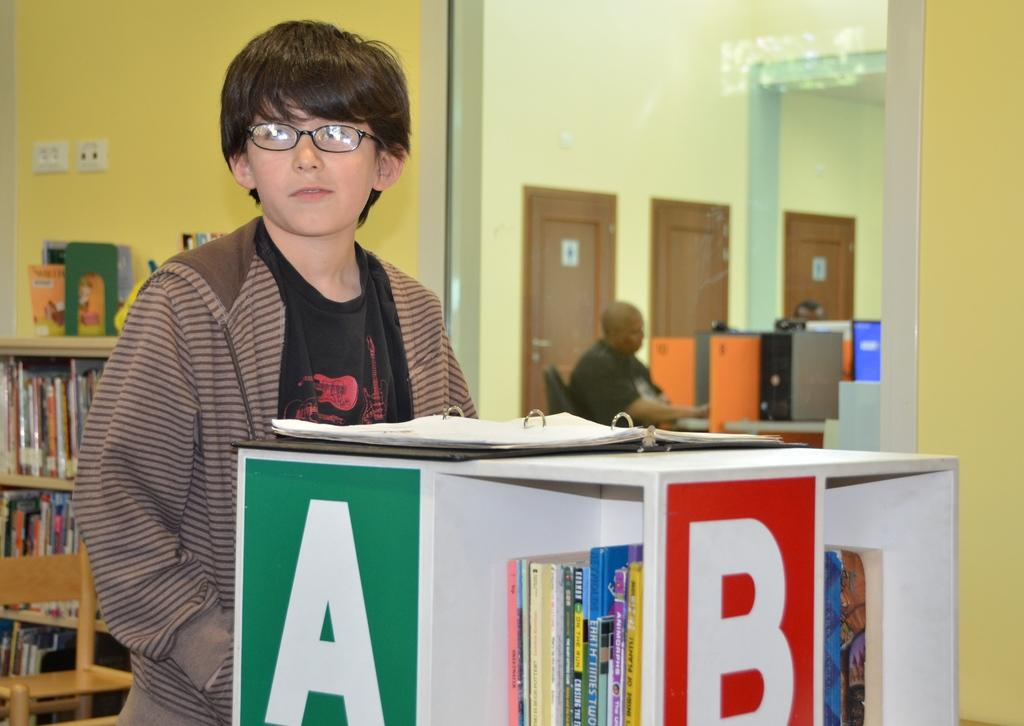<image>
Provide a brief description of the given image. A young boy stands in front of a shelf with the letters A and B on it. 